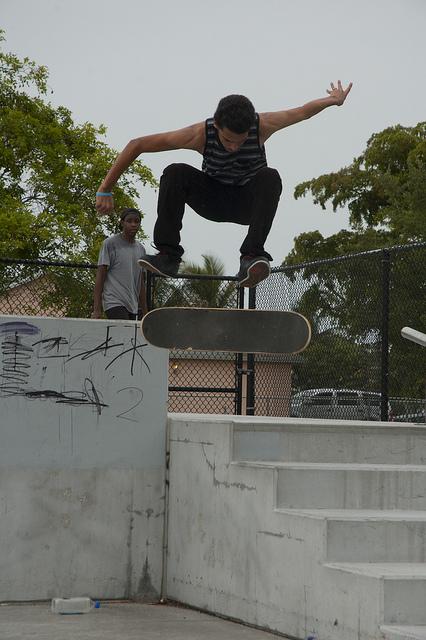Is the boy jumping off the board?
Write a very short answer. Yes. Is there graffiti on the wall?
Be succinct. Yes. What color is the skateboard?
Give a very brief answer. Black. Is he doing a trick?
Keep it brief. Yes. 